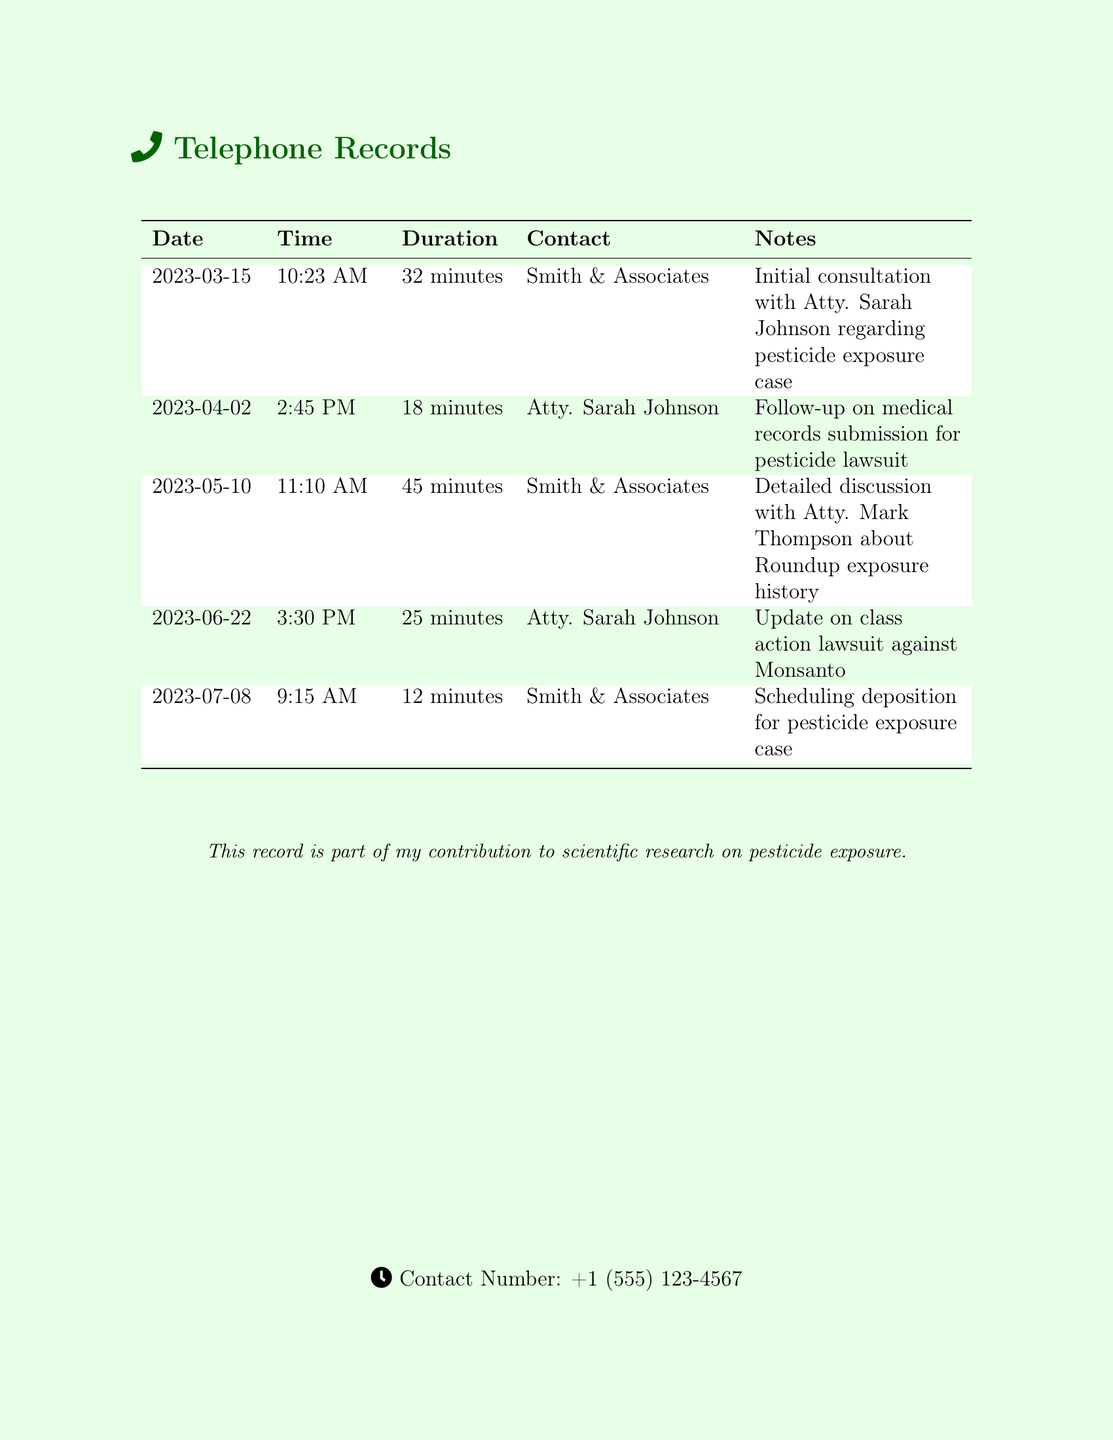What date did the initial consultation take place? The initial consultation is recorded on the document and appears on the date 2023-03-15.
Answer: 2023-03-15 Who was the lawyer contacted for the follow-up on medical records? The notes indicate a follow-up with Atty. Sarah Johnson for medical records submission.
Answer: Atty. Sarah Johnson How long was the conversation about Roundup exposure? The duration of the conversation on that date is specified as 45 minutes.
Answer: 45 minutes What was scheduled during the call on July 8? The notes specify that the call was for scheduling a deposition regarding the pesticide exposure case.
Answer: Scheduling deposition How many contacts were made with Smith & Associates? The table shows that there were three instances of contact listed with Smith & Associates.
Answer: Three What is the purpose of these telephone records? The document explicitly mentions the records are part of a contribution to scientific research on pesticide exposure.
Answer: Contribution to scientific research What time was the follow-up conversation on April 2? According to the document, the follow-up conversation took place at 2:45 PM.
Answer: 2:45 PM Who was updated about the class action lawsuit against Monsanto? Atty. Sarah Johnson is noted as the contact for the update on the lawsuit.
Answer: Atty. Sarah Johnson What type of lawsuit was discussed in these records? The records pertain to a lawsuit regarding pesticide exposure.
Answer: Pesticide exposure lawsuit 